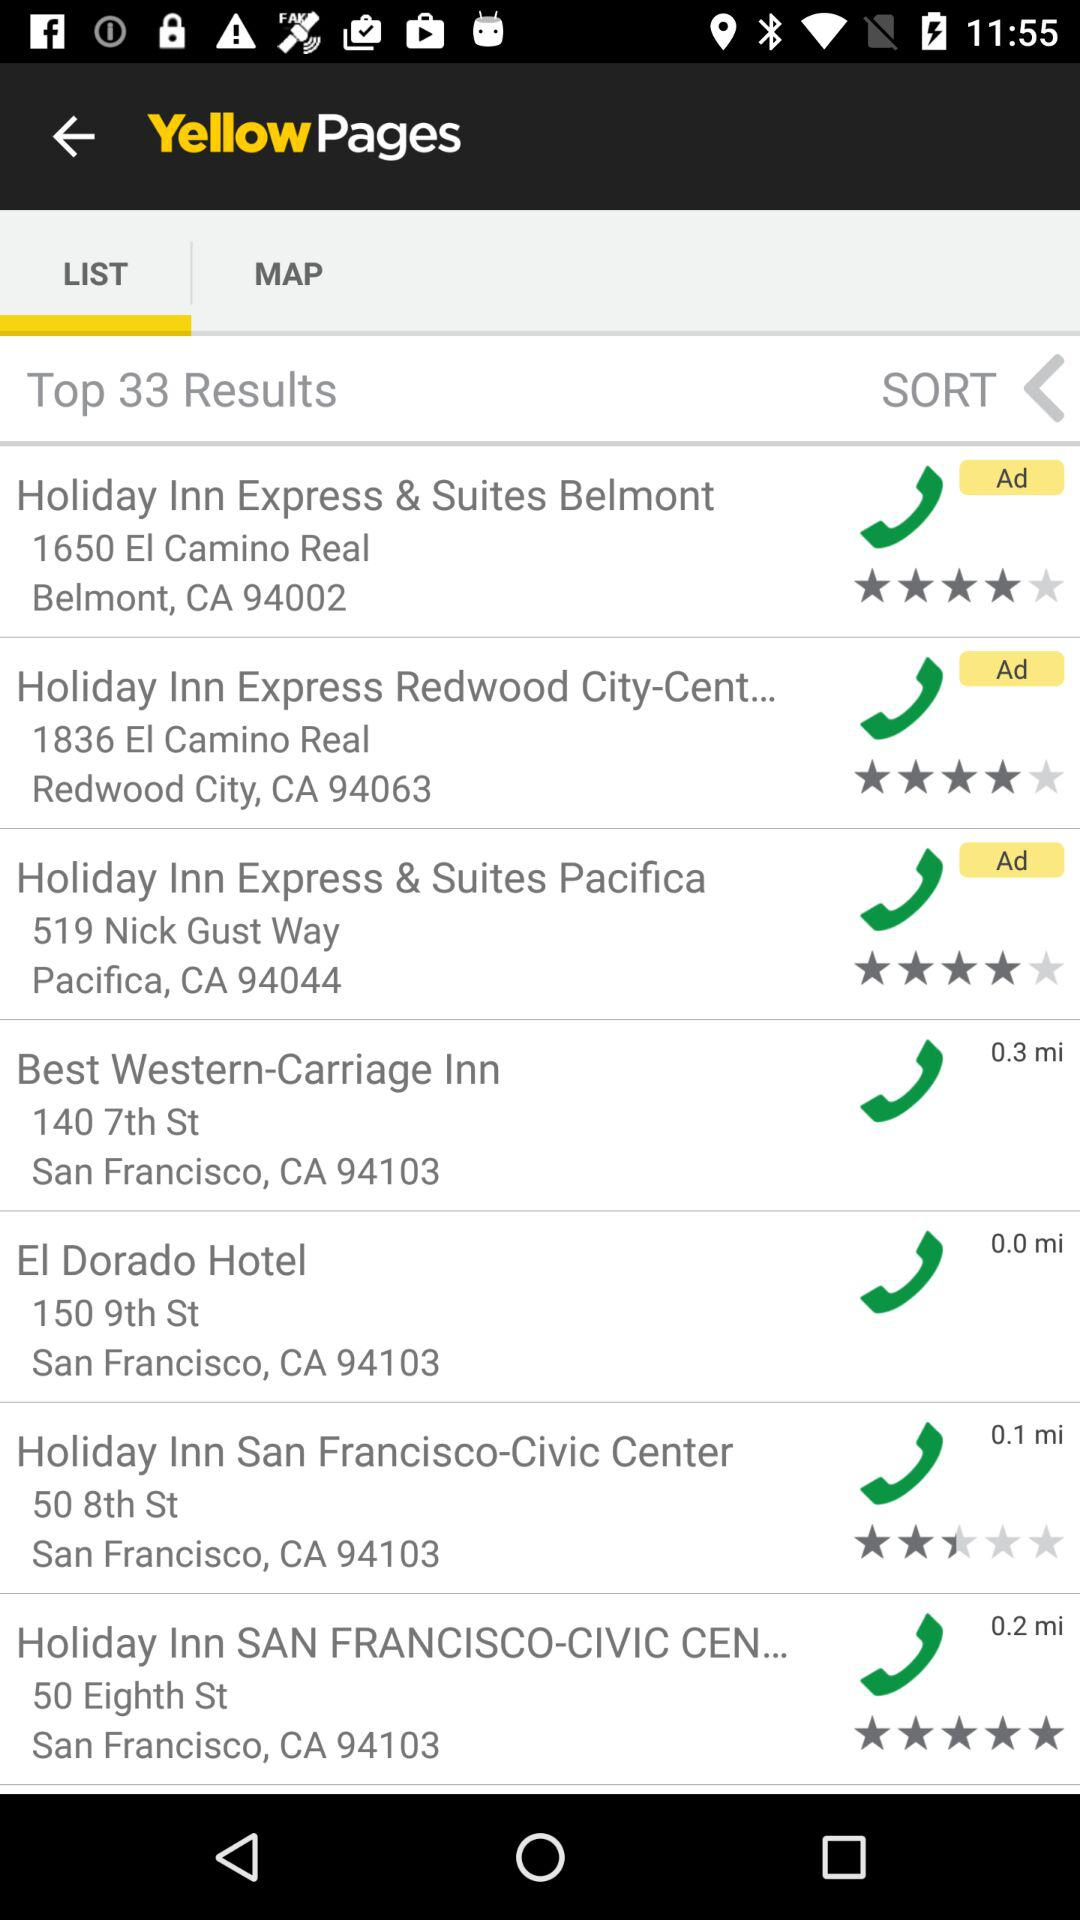What is the number of top results? The number of top results is 33. 